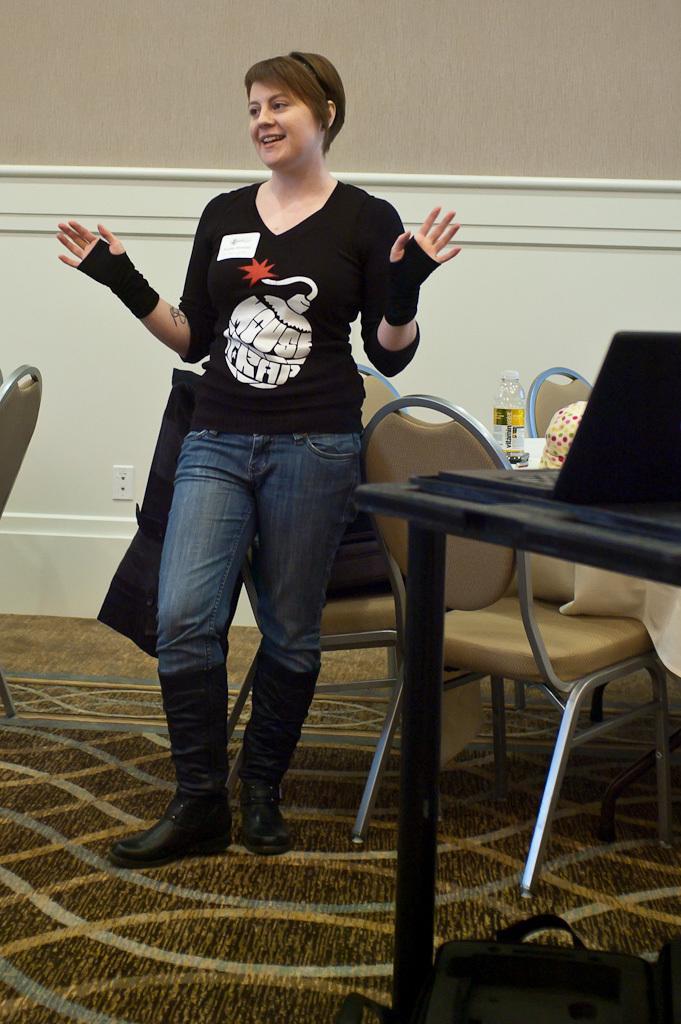Could you give a brief overview of what you see in this image? In this image I can see a woman is standing, I can also see smile on her face. In the background I can see few chairs and a table. I can see a laptop on this table. 